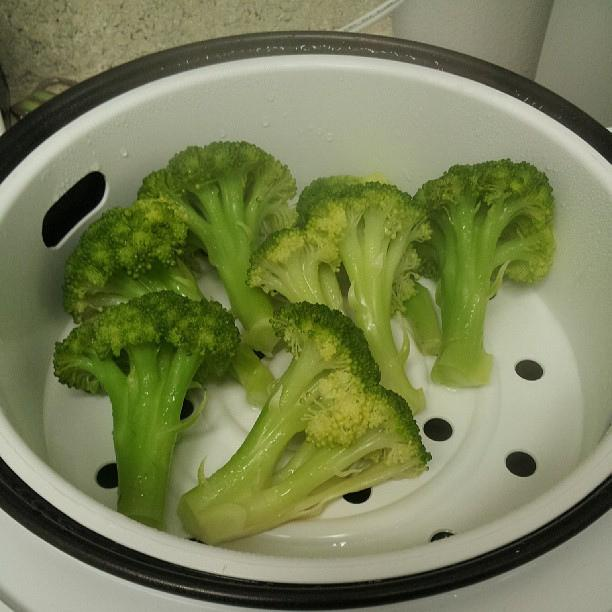What is the method being used to cook the broccoli? steam 